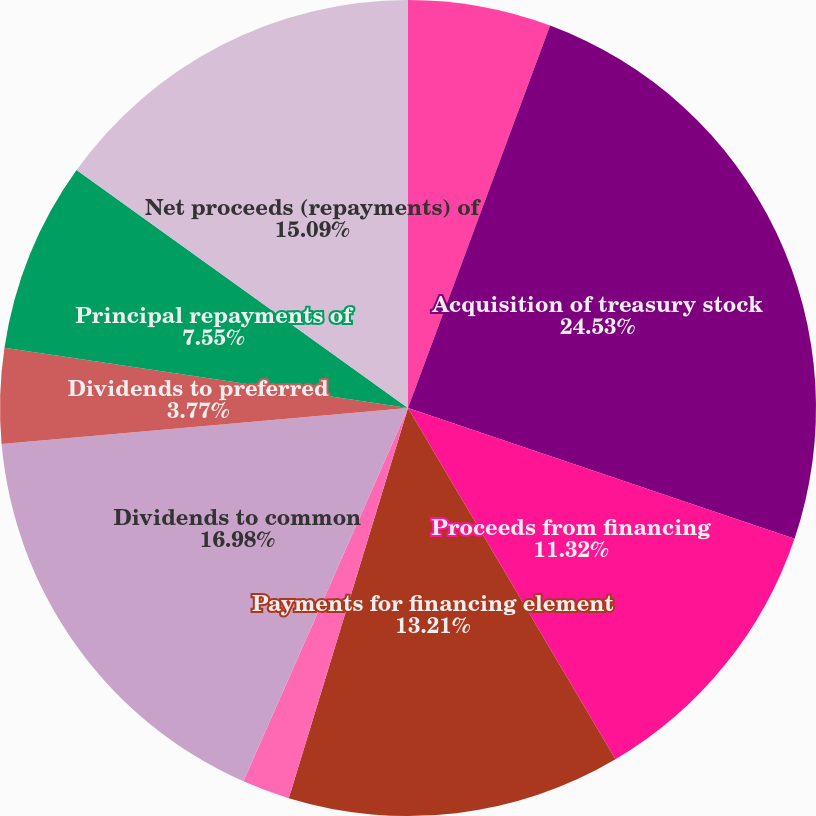Convert chart. <chart><loc_0><loc_0><loc_500><loc_500><pie_chart><fcel>Issuance of common stock<fcel>Acquisition of treasury stock<fcel>Proceeds from financing<fcel>Payments for financing element<fcel>Excess tax benefits from<fcel>Dividends to common<fcel>Dividends to preferred<fcel>Issuance of long-term debt<fcel>Principal repayments of<fcel>Net proceeds (repayments) of<nl><fcel>5.66%<fcel>24.53%<fcel>11.32%<fcel>13.21%<fcel>1.89%<fcel>16.98%<fcel>3.77%<fcel>0.0%<fcel>7.55%<fcel>15.09%<nl></chart> 